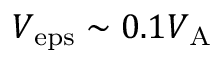Convert formula to latex. <formula><loc_0><loc_0><loc_500><loc_500>V _ { e p s } \sim 0 . 1 V _ { A }</formula> 